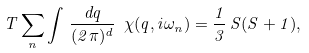Convert formula to latex. <formula><loc_0><loc_0><loc_500><loc_500>T \sum _ { n } \int \, \frac { d { q } } { ( 2 \pi ) ^ { d } } \ \chi ( { q } , i \omega _ { n } ) = \frac { 1 } { 3 } \, S ( S + 1 ) ,</formula> 